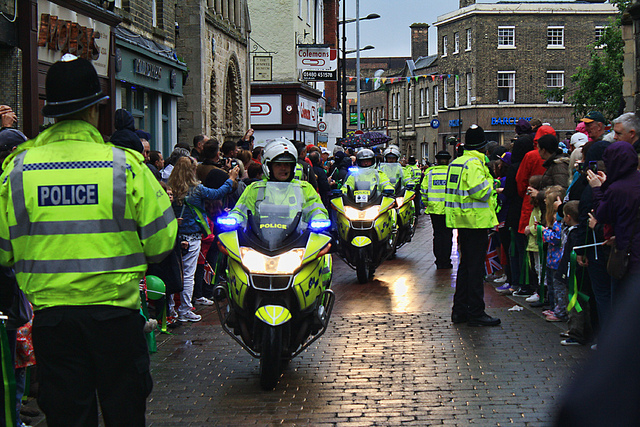Identify the text contained in this image. POLICE POLICE Colemans 